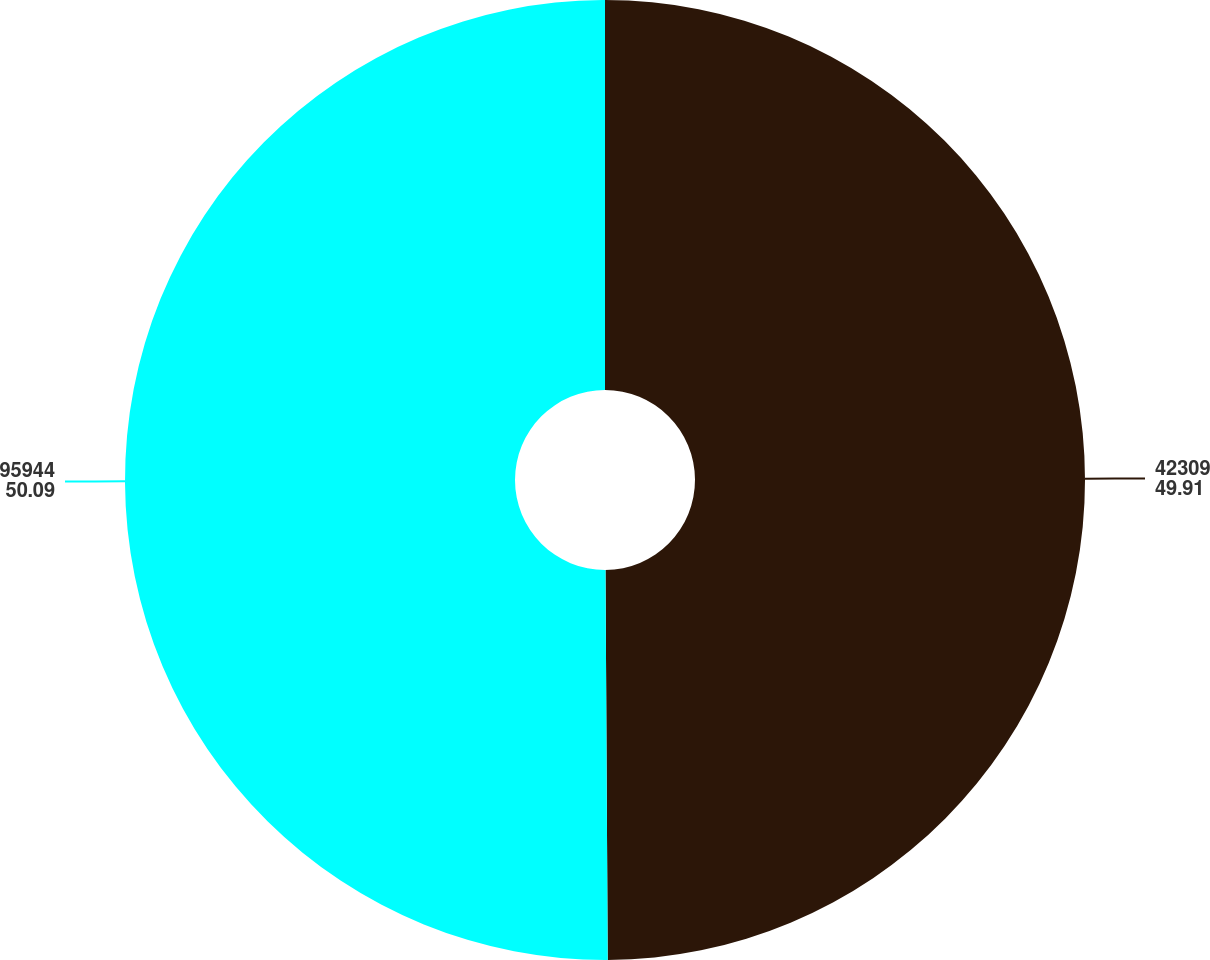Convert chart. <chart><loc_0><loc_0><loc_500><loc_500><pie_chart><fcel>42309<fcel>95944<nl><fcel>49.91%<fcel>50.09%<nl></chart> 